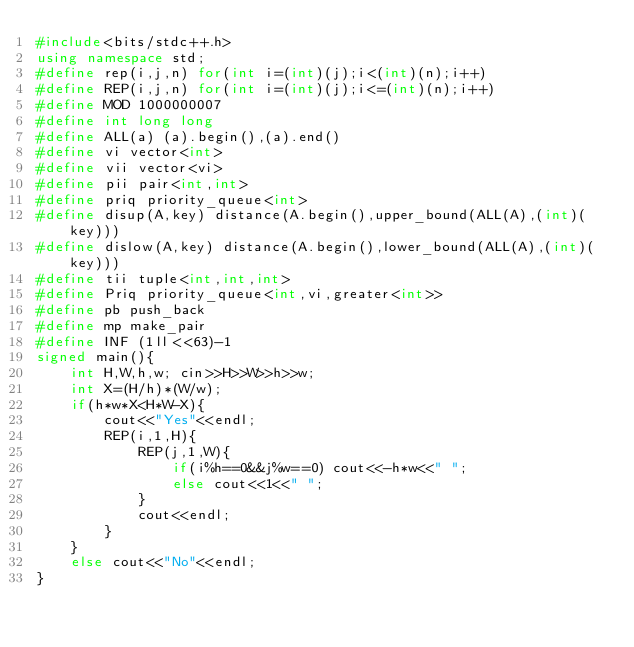<code> <loc_0><loc_0><loc_500><loc_500><_C++_>#include<bits/stdc++.h>
using namespace std;
#define rep(i,j,n) for(int i=(int)(j);i<(int)(n);i++)
#define REP(i,j,n) for(int i=(int)(j);i<=(int)(n);i++)
#define MOD 1000000007
#define int long long
#define ALL(a) (a).begin(),(a).end()
#define vi vector<int>
#define vii vector<vi>
#define pii pair<int,int>
#define priq priority_queue<int>
#define disup(A,key) distance(A.begin(),upper_bound(ALL(A),(int)(key)))
#define dislow(A,key) distance(A.begin(),lower_bound(ALL(A),(int)(key)))
#define tii tuple<int,int,int>
#define Priq priority_queue<int,vi,greater<int>>
#define pb push_back
#define mp make_pair
#define INF (1ll<<63)-1
signed main(){
    int H,W,h,w; cin>>H>>W>>h>>w;
    int X=(H/h)*(W/w);
    if(h*w*X<H*W-X){
        cout<<"Yes"<<endl;
        REP(i,1,H){
            REP(j,1,W){
                if(i%h==0&&j%w==0) cout<<-h*w<<" ";
                else cout<<1<<" ";
            }
            cout<<endl;
        }
    }
    else cout<<"No"<<endl;
}</code> 